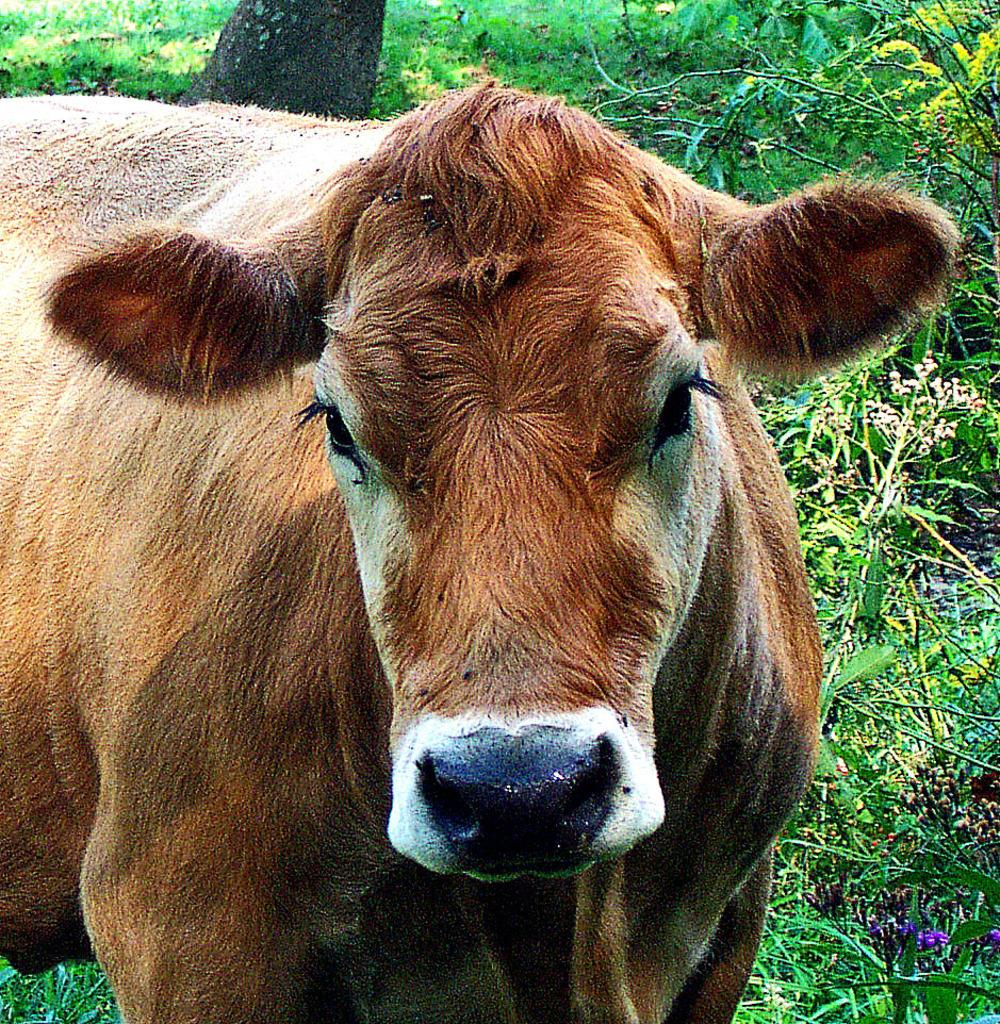What animal is present in the image? There is a cow in the image. What is the cow's position in the image? The cow is standing on the ground. What type of vegetation can be seen on the ground? There are plants and grass on the ground. Can you describe any other natural elements in the image? There is a tree trunk visible in the image. What type of leather is the cow wearing in the image? There is no leather present in the image, nor is the cow wearing any clothing. 